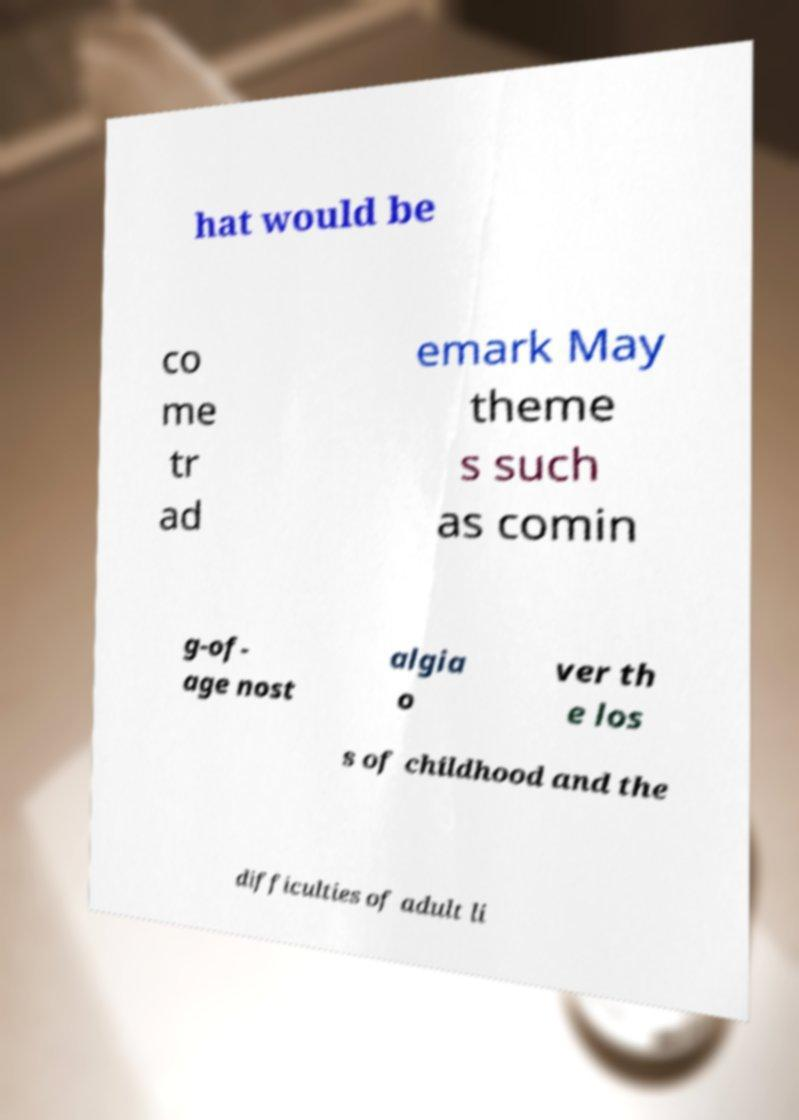For documentation purposes, I need the text within this image transcribed. Could you provide that? hat would be co me tr ad emark May theme s such as comin g-of- age nost algia o ver th e los s of childhood and the difficulties of adult li 